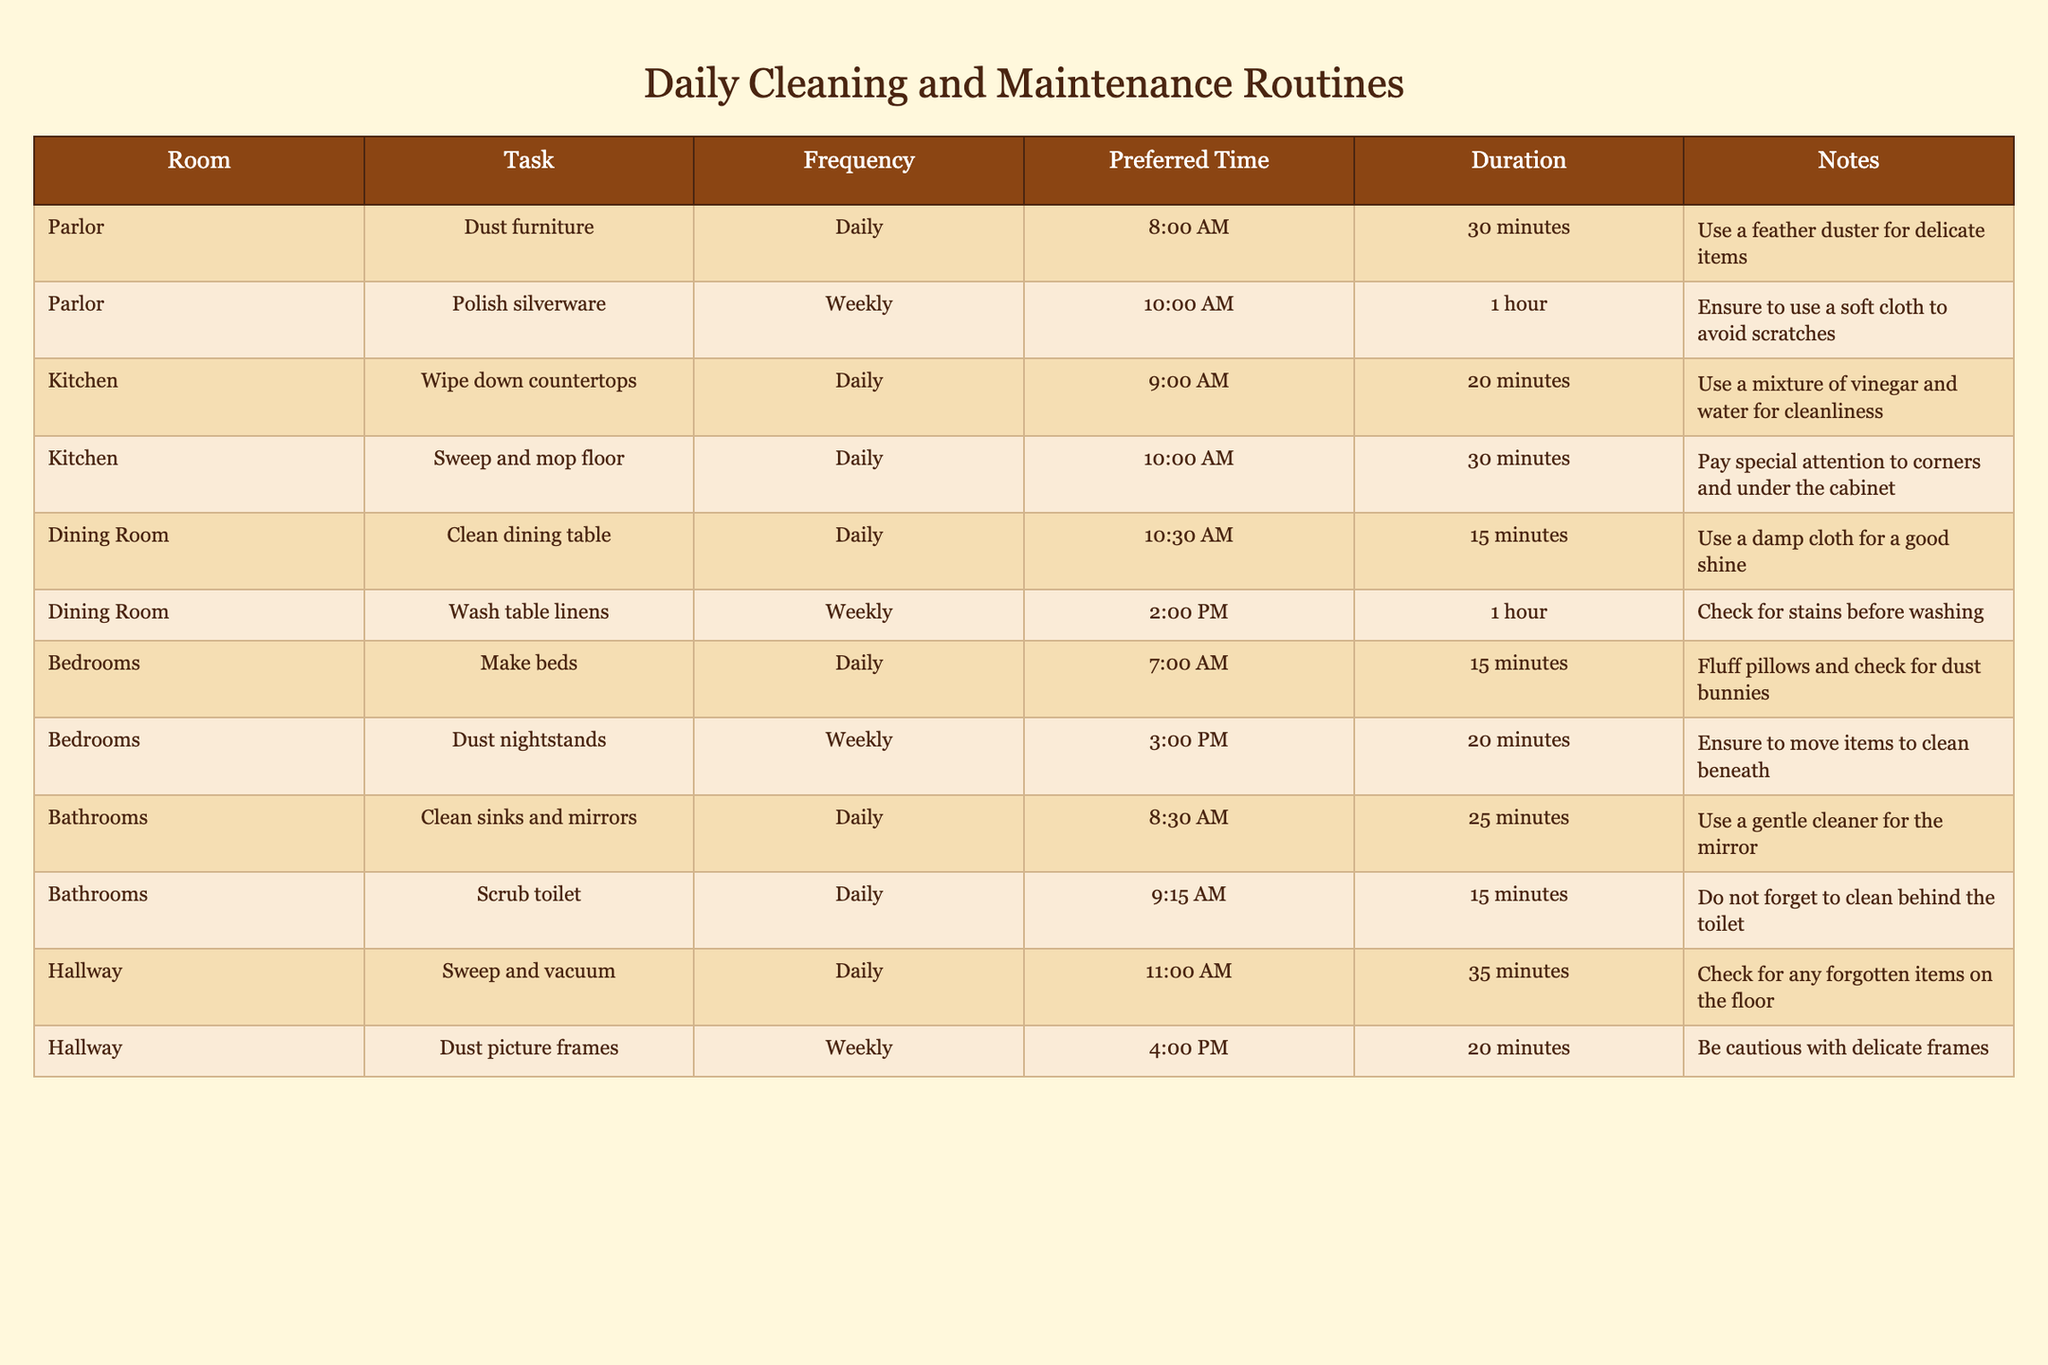What is the preferred time for dusting the furniture in the parlor? The table indicates that the task of dusting furniture in the parlor is scheduled for 8:00 AM.
Answer: 8:00 AM How long does it take to polish the silverware in the parlor? According to the table, polishing silverware is set to take 1 hour.
Answer: 1 hour What is the frequency of sweeping and mopping the kitchen floor? The table shows that sweeping and mopping the kitchen floor is a daily task.
Answer: Daily Which task takes the longest duration in the dining room? By comparing the durations listed, washing table linens at 1 hour is the longest task in the dining room, whereas cleaning the dining table takes only 15 minutes.
Answer: Washing table linens Are the nightstands in the bedrooms dusted daily? The table indicates that dusting nightstands occurs weekly, not daily.
Answer: No If you combine the daily cleaning tasks' durations in the kitchen, how much time is spent in total? In the kitchen, wiping down countertops takes 20 minutes and sweeping and mopping takes 30 minutes. Therefore, adding them gives a total of 20 + 30 = 50 minutes for daily cleaning tasks.
Answer: 50 minutes How often are the picture frames in the hallway dusted? The table specifies that dusting picture frames in the hallway is done on a weekly basis.
Answer: Weekly What is the task duration for cleaning sinks and mirrors in the bathrooms? The duration for cleaning sinks and mirrors is recorded as 25 minutes in the table.
Answer: 25 minutes Which daily task has the earliest start time and how long does it take? Making the beds in the bedrooms starts at 7:00 AM and takes 15 minutes; this is the earliest daily task listed.
Answer: 7:00 AM, 15 minutes 